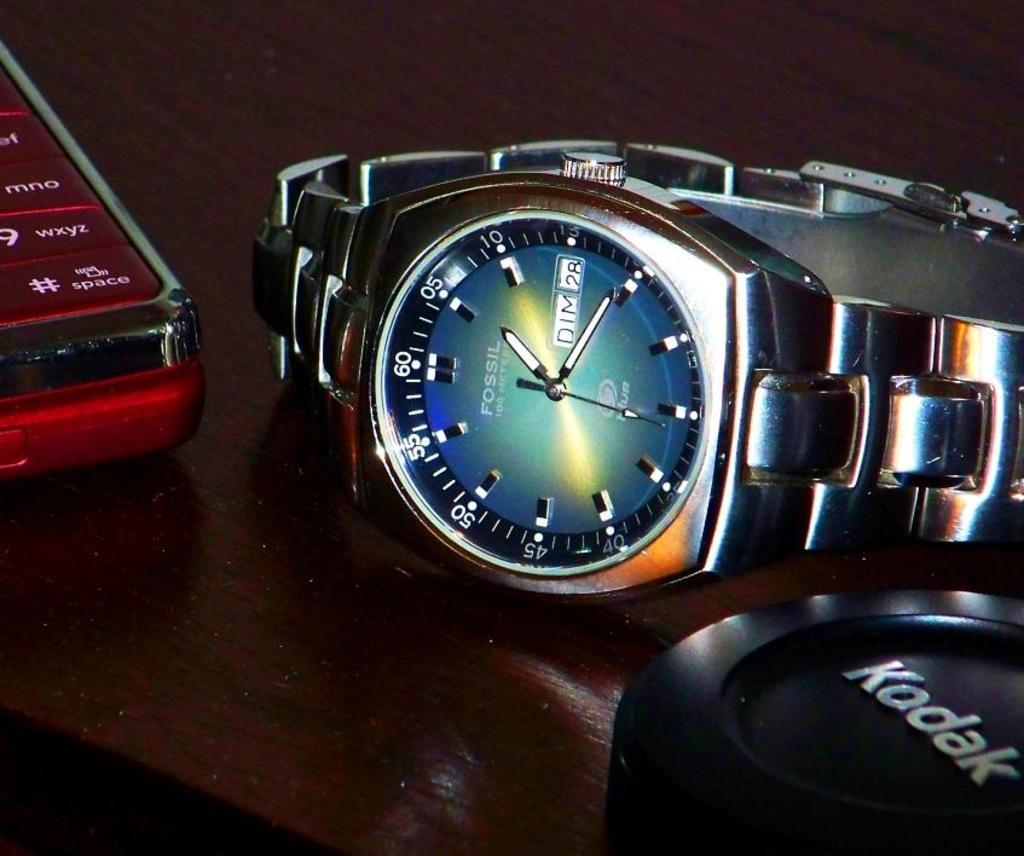Provide a one-sentence caption for the provided image. Silver Fossil watch placed on a table next to a Kodak product. 